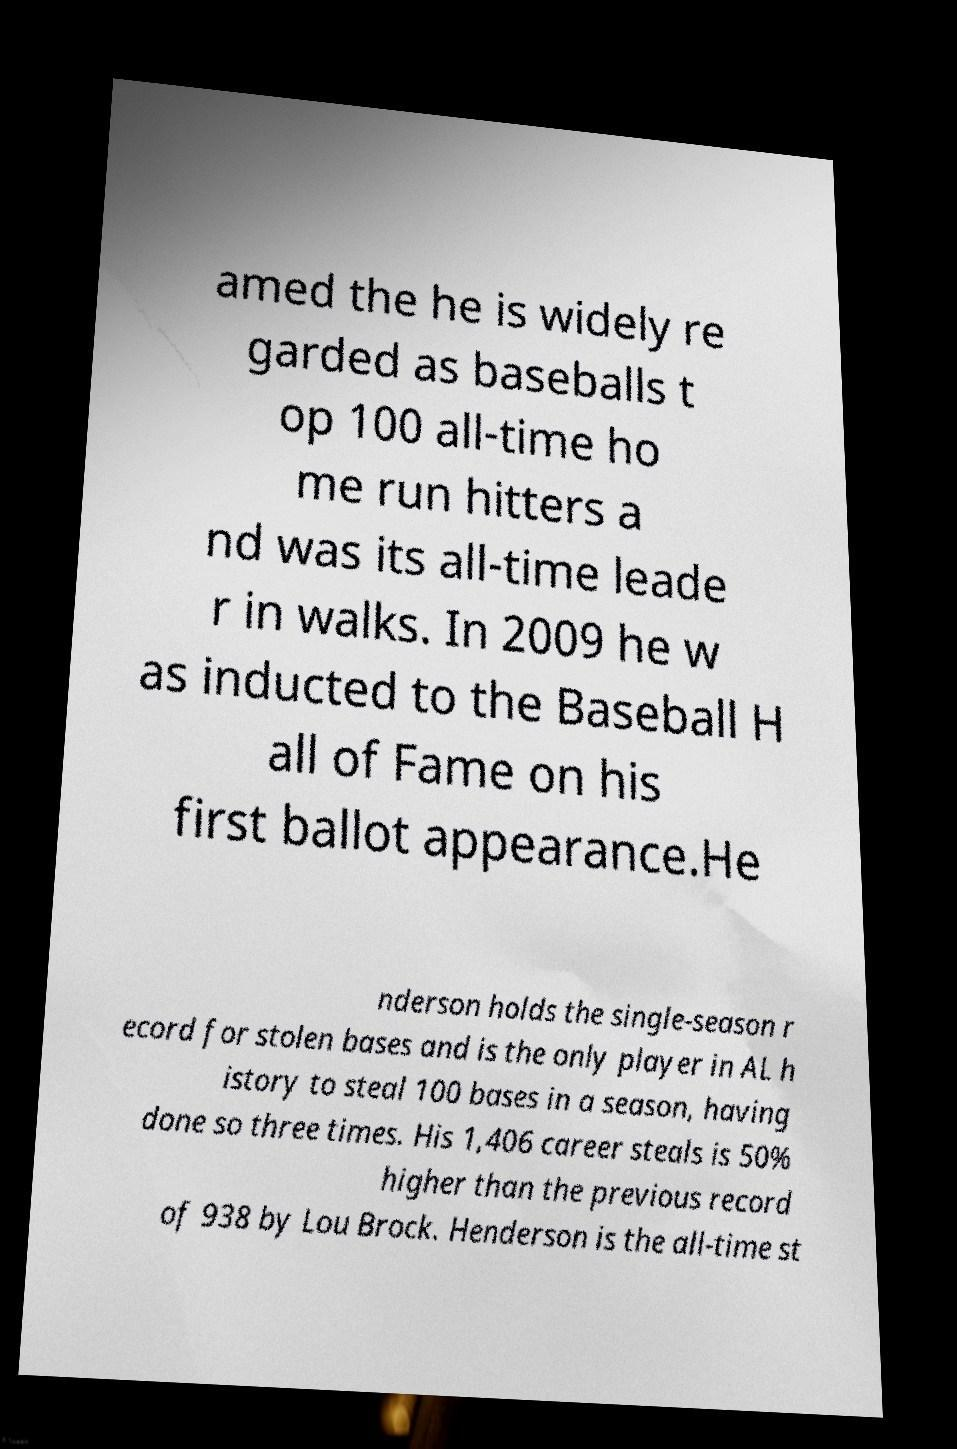I need the written content from this picture converted into text. Can you do that? amed the he is widely re garded as baseballs t op 100 all-time ho me run hitters a nd was its all-time leade r in walks. In 2009 he w as inducted to the Baseball H all of Fame on his first ballot appearance.He nderson holds the single-season r ecord for stolen bases and is the only player in AL h istory to steal 100 bases in a season, having done so three times. His 1,406 career steals is 50% higher than the previous record of 938 by Lou Brock. Henderson is the all-time st 